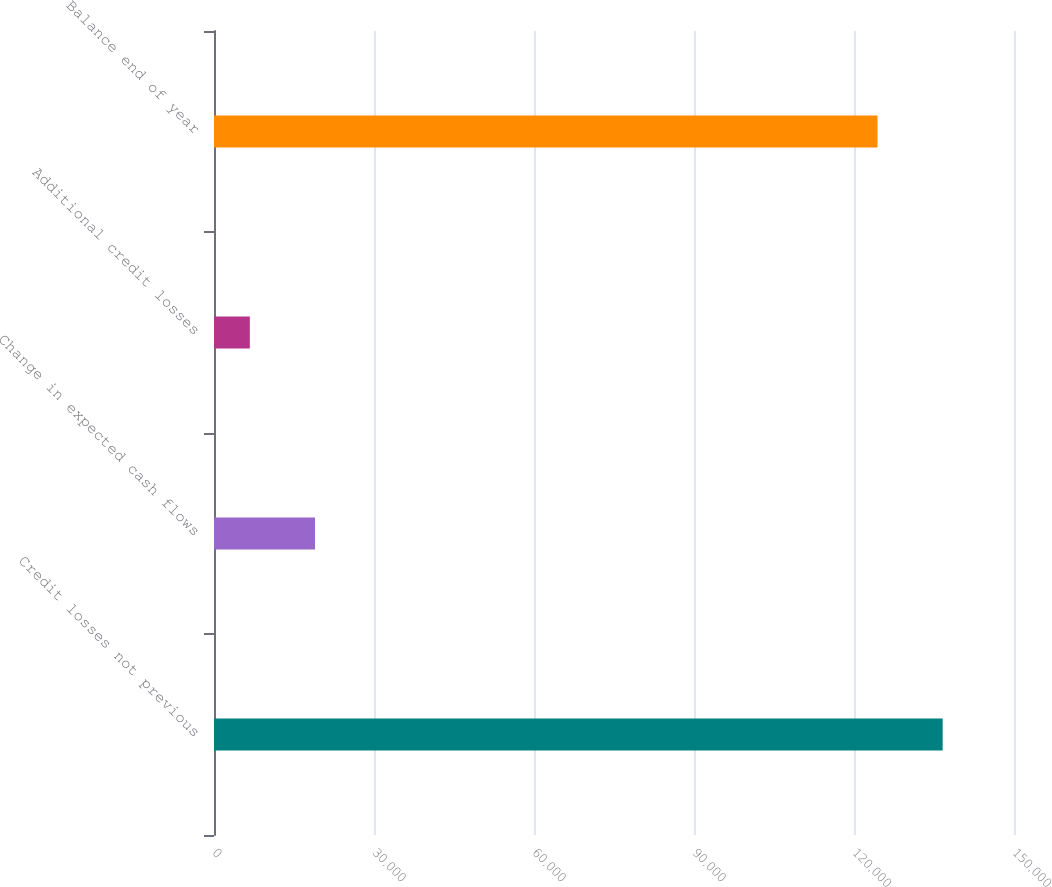Convert chart to OTSL. <chart><loc_0><loc_0><loc_500><loc_500><bar_chart><fcel>Credit losses not previous<fcel>Change in expected cash flows<fcel>Additional credit losses<fcel>Balance end of year<nl><fcel>136626<fcel>18934.5<fcel>6717<fcel>124408<nl></chart> 